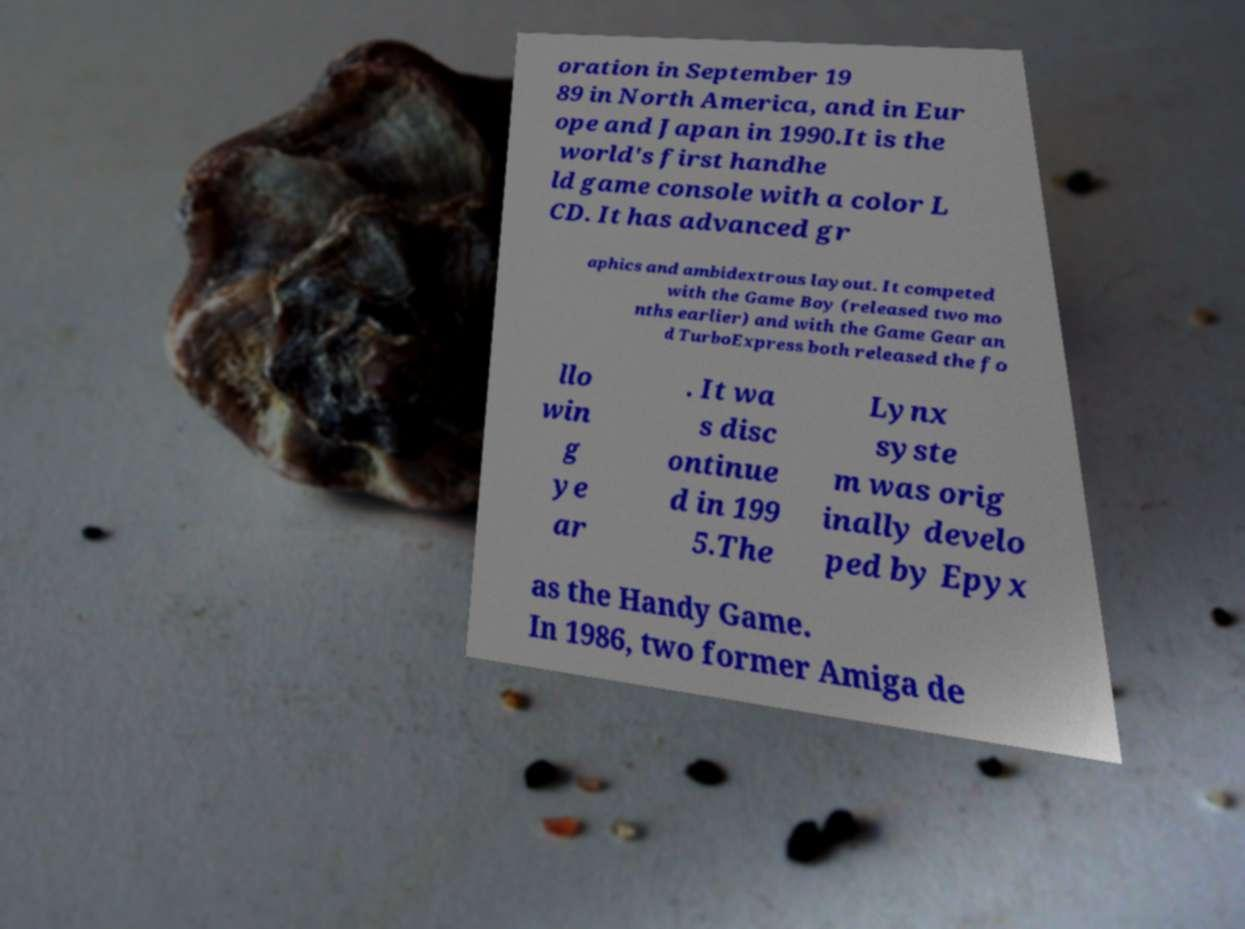Could you extract and type out the text from this image? oration in September 19 89 in North America, and in Eur ope and Japan in 1990.It is the world's first handhe ld game console with a color L CD. It has advanced gr aphics and ambidextrous layout. It competed with the Game Boy (released two mo nths earlier) and with the Game Gear an d TurboExpress both released the fo llo win g ye ar . It wa s disc ontinue d in 199 5.The Lynx syste m was orig inally develo ped by Epyx as the Handy Game. In 1986, two former Amiga de 